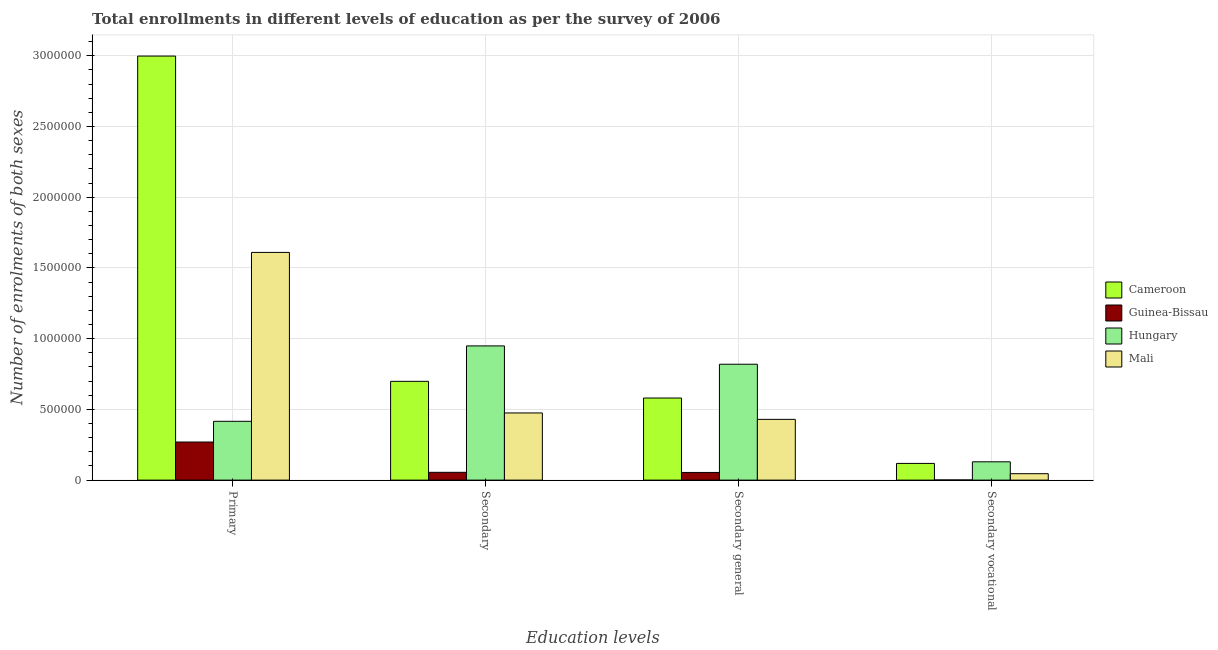What is the label of the 1st group of bars from the left?
Your answer should be very brief. Primary. What is the number of enrolments in secondary vocational education in Mali?
Your answer should be very brief. 4.54e+04. Across all countries, what is the maximum number of enrolments in primary education?
Provide a short and direct response. 3.00e+06. Across all countries, what is the minimum number of enrolments in secondary education?
Keep it short and to the point. 5.52e+04. In which country was the number of enrolments in secondary education maximum?
Offer a very short reply. Hungary. In which country was the number of enrolments in secondary vocational education minimum?
Ensure brevity in your answer.  Guinea-Bissau. What is the total number of enrolments in primary education in the graph?
Offer a terse response. 5.29e+06. What is the difference between the number of enrolments in secondary vocational education in Guinea-Bissau and that in Cameroon?
Your response must be concise. -1.17e+05. What is the difference between the number of enrolments in secondary general education in Guinea-Bissau and the number of enrolments in secondary education in Cameroon?
Your answer should be very brief. -6.44e+05. What is the average number of enrolments in primary education per country?
Your response must be concise. 1.32e+06. What is the difference between the number of enrolments in secondary vocational education and number of enrolments in primary education in Guinea-Bissau?
Ensure brevity in your answer.  -2.68e+05. In how many countries, is the number of enrolments in secondary education greater than 300000 ?
Keep it short and to the point. 3. What is the ratio of the number of enrolments in secondary general education in Cameroon to that in Hungary?
Offer a very short reply. 0.71. Is the difference between the number of enrolments in secondary vocational education in Cameroon and Hungary greater than the difference between the number of enrolments in secondary education in Cameroon and Hungary?
Ensure brevity in your answer.  Yes. What is the difference between the highest and the second highest number of enrolments in secondary vocational education?
Give a very brief answer. 1.14e+04. What is the difference between the highest and the lowest number of enrolments in secondary vocational education?
Provide a succinct answer. 1.28e+05. Is the sum of the number of enrolments in secondary general education in Cameroon and Guinea-Bissau greater than the maximum number of enrolments in primary education across all countries?
Your response must be concise. No. Is it the case that in every country, the sum of the number of enrolments in secondary vocational education and number of enrolments in secondary education is greater than the sum of number of enrolments in primary education and number of enrolments in secondary general education?
Make the answer very short. No. What does the 4th bar from the left in Primary represents?
Give a very brief answer. Mali. What does the 4th bar from the right in Secondary represents?
Your answer should be compact. Cameroon. How many bars are there?
Make the answer very short. 16. How many countries are there in the graph?
Offer a very short reply. 4. Does the graph contain grids?
Give a very brief answer. Yes. Where does the legend appear in the graph?
Keep it short and to the point. Center right. How many legend labels are there?
Your answer should be very brief. 4. What is the title of the graph?
Offer a terse response. Total enrollments in different levels of education as per the survey of 2006. Does "Guatemala" appear as one of the legend labels in the graph?
Offer a very short reply. No. What is the label or title of the X-axis?
Keep it short and to the point. Education levels. What is the label or title of the Y-axis?
Keep it short and to the point. Number of enrolments of both sexes. What is the Number of enrolments of both sexes of Cameroon in Primary?
Offer a very short reply. 3.00e+06. What is the Number of enrolments of both sexes of Guinea-Bissau in Primary?
Your response must be concise. 2.69e+05. What is the Number of enrolments of both sexes in Hungary in Primary?
Your answer should be very brief. 4.16e+05. What is the Number of enrolments of both sexes of Mali in Primary?
Provide a short and direct response. 1.61e+06. What is the Number of enrolments of both sexes of Cameroon in Secondary?
Provide a succinct answer. 6.98e+05. What is the Number of enrolments of both sexes in Guinea-Bissau in Secondary?
Your response must be concise. 5.52e+04. What is the Number of enrolments of both sexes of Hungary in Secondary?
Your answer should be very brief. 9.49e+05. What is the Number of enrolments of both sexes in Mali in Secondary?
Keep it short and to the point. 4.75e+05. What is the Number of enrolments of both sexes in Cameroon in Secondary general?
Keep it short and to the point. 5.80e+05. What is the Number of enrolments of both sexes in Guinea-Bissau in Secondary general?
Offer a very short reply. 5.42e+04. What is the Number of enrolments of both sexes of Hungary in Secondary general?
Your answer should be very brief. 8.19e+05. What is the Number of enrolments of both sexes in Mali in Secondary general?
Ensure brevity in your answer.  4.30e+05. What is the Number of enrolments of both sexes in Cameroon in Secondary vocational?
Give a very brief answer. 1.18e+05. What is the Number of enrolments of both sexes in Guinea-Bissau in Secondary vocational?
Provide a short and direct response. 977. What is the Number of enrolments of both sexes in Hungary in Secondary vocational?
Provide a short and direct response. 1.29e+05. What is the Number of enrolments of both sexes in Mali in Secondary vocational?
Your answer should be very brief. 4.54e+04. Across all Education levels, what is the maximum Number of enrolments of both sexes of Cameroon?
Make the answer very short. 3.00e+06. Across all Education levels, what is the maximum Number of enrolments of both sexes in Guinea-Bissau?
Provide a short and direct response. 2.69e+05. Across all Education levels, what is the maximum Number of enrolments of both sexes in Hungary?
Ensure brevity in your answer.  9.49e+05. Across all Education levels, what is the maximum Number of enrolments of both sexes in Mali?
Keep it short and to the point. 1.61e+06. Across all Education levels, what is the minimum Number of enrolments of both sexes in Cameroon?
Your answer should be compact. 1.18e+05. Across all Education levels, what is the minimum Number of enrolments of both sexes in Guinea-Bissau?
Your response must be concise. 977. Across all Education levels, what is the minimum Number of enrolments of both sexes of Hungary?
Your answer should be very brief. 1.29e+05. Across all Education levels, what is the minimum Number of enrolments of both sexes of Mali?
Keep it short and to the point. 4.54e+04. What is the total Number of enrolments of both sexes of Cameroon in the graph?
Offer a terse response. 4.40e+06. What is the total Number of enrolments of both sexes in Guinea-Bissau in the graph?
Ensure brevity in your answer.  3.80e+05. What is the total Number of enrolments of both sexes in Hungary in the graph?
Offer a very short reply. 2.31e+06. What is the total Number of enrolments of both sexes in Mali in the graph?
Offer a terse response. 2.56e+06. What is the difference between the Number of enrolments of both sexes in Cameroon in Primary and that in Secondary?
Offer a terse response. 2.30e+06. What is the difference between the Number of enrolments of both sexes of Guinea-Bissau in Primary and that in Secondary?
Offer a terse response. 2.14e+05. What is the difference between the Number of enrolments of both sexes of Hungary in Primary and that in Secondary?
Provide a short and direct response. -5.33e+05. What is the difference between the Number of enrolments of both sexes of Mali in Primary and that in Secondary?
Provide a succinct answer. 1.14e+06. What is the difference between the Number of enrolments of both sexes in Cameroon in Primary and that in Secondary general?
Provide a succinct answer. 2.42e+06. What is the difference between the Number of enrolments of both sexes of Guinea-Bissau in Primary and that in Secondary general?
Provide a succinct answer. 2.15e+05. What is the difference between the Number of enrolments of both sexes of Hungary in Primary and that in Secondary general?
Keep it short and to the point. -4.04e+05. What is the difference between the Number of enrolments of both sexes of Mali in Primary and that in Secondary general?
Give a very brief answer. 1.18e+06. What is the difference between the Number of enrolments of both sexes of Cameroon in Primary and that in Secondary vocational?
Your answer should be compact. 2.88e+06. What is the difference between the Number of enrolments of both sexes in Guinea-Bissau in Primary and that in Secondary vocational?
Offer a very short reply. 2.68e+05. What is the difference between the Number of enrolments of both sexes in Hungary in Primary and that in Secondary vocational?
Your answer should be compact. 2.86e+05. What is the difference between the Number of enrolments of both sexes in Mali in Primary and that in Secondary vocational?
Make the answer very short. 1.56e+06. What is the difference between the Number of enrolments of both sexes in Cameroon in Secondary and that in Secondary general?
Make the answer very short. 1.18e+05. What is the difference between the Number of enrolments of both sexes of Guinea-Bissau in Secondary and that in Secondary general?
Give a very brief answer. 977. What is the difference between the Number of enrolments of both sexes in Hungary in Secondary and that in Secondary general?
Your response must be concise. 1.29e+05. What is the difference between the Number of enrolments of both sexes of Mali in Secondary and that in Secondary general?
Give a very brief answer. 4.54e+04. What is the difference between the Number of enrolments of both sexes of Cameroon in Secondary and that in Secondary vocational?
Provide a short and direct response. 5.80e+05. What is the difference between the Number of enrolments of both sexes of Guinea-Bissau in Secondary and that in Secondary vocational?
Your answer should be compact. 5.42e+04. What is the difference between the Number of enrolments of both sexes of Hungary in Secondary and that in Secondary vocational?
Your response must be concise. 8.19e+05. What is the difference between the Number of enrolments of both sexes of Mali in Secondary and that in Secondary vocational?
Give a very brief answer. 4.30e+05. What is the difference between the Number of enrolments of both sexes in Cameroon in Secondary general and that in Secondary vocational?
Offer a terse response. 4.62e+05. What is the difference between the Number of enrolments of both sexes in Guinea-Bissau in Secondary general and that in Secondary vocational?
Your answer should be very brief. 5.32e+04. What is the difference between the Number of enrolments of both sexes in Hungary in Secondary general and that in Secondary vocational?
Your answer should be very brief. 6.90e+05. What is the difference between the Number of enrolments of both sexes in Mali in Secondary general and that in Secondary vocational?
Your answer should be compact. 3.84e+05. What is the difference between the Number of enrolments of both sexes of Cameroon in Primary and the Number of enrolments of both sexes of Guinea-Bissau in Secondary?
Your response must be concise. 2.94e+06. What is the difference between the Number of enrolments of both sexes of Cameroon in Primary and the Number of enrolments of both sexes of Hungary in Secondary?
Provide a succinct answer. 2.05e+06. What is the difference between the Number of enrolments of both sexes in Cameroon in Primary and the Number of enrolments of both sexes in Mali in Secondary?
Provide a short and direct response. 2.52e+06. What is the difference between the Number of enrolments of both sexes of Guinea-Bissau in Primary and the Number of enrolments of both sexes of Hungary in Secondary?
Offer a very short reply. -6.80e+05. What is the difference between the Number of enrolments of both sexes of Guinea-Bissau in Primary and the Number of enrolments of both sexes of Mali in Secondary?
Give a very brief answer. -2.06e+05. What is the difference between the Number of enrolments of both sexes in Hungary in Primary and the Number of enrolments of both sexes in Mali in Secondary?
Your answer should be very brief. -5.91e+04. What is the difference between the Number of enrolments of both sexes of Cameroon in Primary and the Number of enrolments of both sexes of Guinea-Bissau in Secondary general?
Make the answer very short. 2.94e+06. What is the difference between the Number of enrolments of both sexes of Cameroon in Primary and the Number of enrolments of both sexes of Hungary in Secondary general?
Your answer should be compact. 2.18e+06. What is the difference between the Number of enrolments of both sexes in Cameroon in Primary and the Number of enrolments of both sexes in Mali in Secondary general?
Offer a very short reply. 2.57e+06. What is the difference between the Number of enrolments of both sexes of Guinea-Bissau in Primary and the Number of enrolments of both sexes of Hungary in Secondary general?
Make the answer very short. -5.50e+05. What is the difference between the Number of enrolments of both sexes of Guinea-Bissau in Primary and the Number of enrolments of both sexes of Mali in Secondary general?
Make the answer very short. -1.60e+05. What is the difference between the Number of enrolments of both sexes of Hungary in Primary and the Number of enrolments of both sexes of Mali in Secondary general?
Provide a short and direct response. -1.37e+04. What is the difference between the Number of enrolments of both sexes in Cameroon in Primary and the Number of enrolments of both sexes in Guinea-Bissau in Secondary vocational?
Provide a succinct answer. 3.00e+06. What is the difference between the Number of enrolments of both sexes in Cameroon in Primary and the Number of enrolments of both sexes in Hungary in Secondary vocational?
Your answer should be compact. 2.87e+06. What is the difference between the Number of enrolments of both sexes in Cameroon in Primary and the Number of enrolments of both sexes in Mali in Secondary vocational?
Provide a succinct answer. 2.95e+06. What is the difference between the Number of enrolments of both sexes of Guinea-Bissau in Primary and the Number of enrolments of both sexes of Hungary in Secondary vocational?
Your response must be concise. 1.40e+05. What is the difference between the Number of enrolments of both sexes of Guinea-Bissau in Primary and the Number of enrolments of both sexes of Mali in Secondary vocational?
Provide a short and direct response. 2.24e+05. What is the difference between the Number of enrolments of both sexes in Hungary in Primary and the Number of enrolments of both sexes in Mali in Secondary vocational?
Keep it short and to the point. 3.70e+05. What is the difference between the Number of enrolments of both sexes of Cameroon in Secondary and the Number of enrolments of both sexes of Guinea-Bissau in Secondary general?
Your answer should be very brief. 6.44e+05. What is the difference between the Number of enrolments of both sexes of Cameroon in Secondary and the Number of enrolments of both sexes of Hungary in Secondary general?
Keep it short and to the point. -1.21e+05. What is the difference between the Number of enrolments of both sexes in Cameroon in Secondary and the Number of enrolments of both sexes in Mali in Secondary general?
Provide a succinct answer. 2.69e+05. What is the difference between the Number of enrolments of both sexes of Guinea-Bissau in Secondary and the Number of enrolments of both sexes of Hungary in Secondary general?
Give a very brief answer. -7.64e+05. What is the difference between the Number of enrolments of both sexes of Guinea-Bissau in Secondary and the Number of enrolments of both sexes of Mali in Secondary general?
Offer a terse response. -3.74e+05. What is the difference between the Number of enrolments of both sexes in Hungary in Secondary and the Number of enrolments of both sexes in Mali in Secondary general?
Offer a terse response. 5.19e+05. What is the difference between the Number of enrolments of both sexes of Cameroon in Secondary and the Number of enrolments of both sexes of Guinea-Bissau in Secondary vocational?
Give a very brief answer. 6.97e+05. What is the difference between the Number of enrolments of both sexes in Cameroon in Secondary and the Number of enrolments of both sexes in Hungary in Secondary vocational?
Your answer should be very brief. 5.69e+05. What is the difference between the Number of enrolments of both sexes in Cameroon in Secondary and the Number of enrolments of both sexes in Mali in Secondary vocational?
Your answer should be very brief. 6.53e+05. What is the difference between the Number of enrolments of both sexes in Guinea-Bissau in Secondary and the Number of enrolments of both sexes in Hungary in Secondary vocational?
Offer a very short reply. -7.43e+04. What is the difference between the Number of enrolments of both sexes in Guinea-Bissau in Secondary and the Number of enrolments of both sexes in Mali in Secondary vocational?
Give a very brief answer. 9754. What is the difference between the Number of enrolments of both sexes of Hungary in Secondary and the Number of enrolments of both sexes of Mali in Secondary vocational?
Offer a very short reply. 9.03e+05. What is the difference between the Number of enrolments of both sexes of Cameroon in Secondary general and the Number of enrolments of both sexes of Guinea-Bissau in Secondary vocational?
Your response must be concise. 5.79e+05. What is the difference between the Number of enrolments of both sexes in Cameroon in Secondary general and the Number of enrolments of both sexes in Hungary in Secondary vocational?
Give a very brief answer. 4.51e+05. What is the difference between the Number of enrolments of both sexes of Cameroon in Secondary general and the Number of enrolments of both sexes of Mali in Secondary vocational?
Offer a very short reply. 5.35e+05. What is the difference between the Number of enrolments of both sexes in Guinea-Bissau in Secondary general and the Number of enrolments of both sexes in Hungary in Secondary vocational?
Give a very brief answer. -7.52e+04. What is the difference between the Number of enrolments of both sexes in Guinea-Bissau in Secondary general and the Number of enrolments of both sexes in Mali in Secondary vocational?
Your response must be concise. 8777. What is the difference between the Number of enrolments of both sexes of Hungary in Secondary general and the Number of enrolments of both sexes of Mali in Secondary vocational?
Your answer should be compact. 7.74e+05. What is the average Number of enrolments of both sexes in Cameroon per Education levels?
Offer a very short reply. 1.10e+06. What is the average Number of enrolments of both sexes in Guinea-Bissau per Education levels?
Keep it short and to the point. 9.49e+04. What is the average Number of enrolments of both sexes of Hungary per Education levels?
Make the answer very short. 5.78e+05. What is the average Number of enrolments of both sexes of Mali per Education levels?
Give a very brief answer. 6.40e+05. What is the difference between the Number of enrolments of both sexes of Cameroon and Number of enrolments of both sexes of Guinea-Bissau in Primary?
Provide a short and direct response. 2.73e+06. What is the difference between the Number of enrolments of both sexes in Cameroon and Number of enrolments of both sexes in Hungary in Primary?
Give a very brief answer. 2.58e+06. What is the difference between the Number of enrolments of both sexes in Cameroon and Number of enrolments of both sexes in Mali in Primary?
Offer a terse response. 1.39e+06. What is the difference between the Number of enrolments of both sexes of Guinea-Bissau and Number of enrolments of both sexes of Hungary in Primary?
Provide a short and direct response. -1.47e+05. What is the difference between the Number of enrolments of both sexes of Guinea-Bissau and Number of enrolments of both sexes of Mali in Primary?
Offer a terse response. -1.34e+06. What is the difference between the Number of enrolments of both sexes of Hungary and Number of enrolments of both sexes of Mali in Primary?
Provide a short and direct response. -1.19e+06. What is the difference between the Number of enrolments of both sexes of Cameroon and Number of enrolments of both sexes of Guinea-Bissau in Secondary?
Ensure brevity in your answer.  6.43e+05. What is the difference between the Number of enrolments of both sexes in Cameroon and Number of enrolments of both sexes in Hungary in Secondary?
Offer a terse response. -2.50e+05. What is the difference between the Number of enrolments of both sexes in Cameroon and Number of enrolments of both sexes in Mali in Secondary?
Provide a short and direct response. 2.23e+05. What is the difference between the Number of enrolments of both sexes in Guinea-Bissau and Number of enrolments of both sexes in Hungary in Secondary?
Make the answer very short. -8.94e+05. What is the difference between the Number of enrolments of both sexes in Guinea-Bissau and Number of enrolments of both sexes in Mali in Secondary?
Provide a short and direct response. -4.20e+05. What is the difference between the Number of enrolments of both sexes of Hungary and Number of enrolments of both sexes of Mali in Secondary?
Keep it short and to the point. 4.74e+05. What is the difference between the Number of enrolments of both sexes of Cameroon and Number of enrolments of both sexes of Guinea-Bissau in Secondary general?
Your answer should be very brief. 5.26e+05. What is the difference between the Number of enrolments of both sexes of Cameroon and Number of enrolments of both sexes of Hungary in Secondary general?
Give a very brief answer. -2.39e+05. What is the difference between the Number of enrolments of both sexes of Cameroon and Number of enrolments of both sexes of Mali in Secondary general?
Provide a short and direct response. 1.51e+05. What is the difference between the Number of enrolments of both sexes in Guinea-Bissau and Number of enrolments of both sexes in Hungary in Secondary general?
Your answer should be compact. -7.65e+05. What is the difference between the Number of enrolments of both sexes in Guinea-Bissau and Number of enrolments of both sexes in Mali in Secondary general?
Give a very brief answer. -3.75e+05. What is the difference between the Number of enrolments of both sexes in Hungary and Number of enrolments of both sexes in Mali in Secondary general?
Your answer should be very brief. 3.90e+05. What is the difference between the Number of enrolments of both sexes in Cameroon and Number of enrolments of both sexes in Guinea-Bissau in Secondary vocational?
Offer a very short reply. 1.17e+05. What is the difference between the Number of enrolments of both sexes in Cameroon and Number of enrolments of both sexes in Hungary in Secondary vocational?
Your answer should be compact. -1.14e+04. What is the difference between the Number of enrolments of both sexes of Cameroon and Number of enrolments of both sexes of Mali in Secondary vocational?
Offer a very short reply. 7.26e+04. What is the difference between the Number of enrolments of both sexes in Guinea-Bissau and Number of enrolments of both sexes in Hungary in Secondary vocational?
Give a very brief answer. -1.28e+05. What is the difference between the Number of enrolments of both sexes in Guinea-Bissau and Number of enrolments of both sexes in Mali in Secondary vocational?
Offer a terse response. -4.44e+04. What is the difference between the Number of enrolments of both sexes in Hungary and Number of enrolments of both sexes in Mali in Secondary vocational?
Make the answer very short. 8.40e+04. What is the ratio of the Number of enrolments of both sexes in Cameroon in Primary to that in Secondary?
Provide a short and direct response. 4.29. What is the ratio of the Number of enrolments of both sexes of Guinea-Bissau in Primary to that in Secondary?
Provide a short and direct response. 4.88. What is the ratio of the Number of enrolments of both sexes of Hungary in Primary to that in Secondary?
Your answer should be very brief. 0.44. What is the ratio of the Number of enrolments of both sexes in Mali in Primary to that in Secondary?
Provide a short and direct response. 3.39. What is the ratio of the Number of enrolments of both sexes of Cameroon in Primary to that in Secondary general?
Provide a succinct answer. 5.17. What is the ratio of the Number of enrolments of both sexes of Guinea-Bissau in Primary to that in Secondary general?
Ensure brevity in your answer.  4.97. What is the ratio of the Number of enrolments of both sexes in Hungary in Primary to that in Secondary general?
Give a very brief answer. 0.51. What is the ratio of the Number of enrolments of both sexes in Mali in Primary to that in Secondary general?
Your response must be concise. 3.75. What is the ratio of the Number of enrolments of both sexes in Cameroon in Primary to that in Secondary vocational?
Offer a very short reply. 25.4. What is the ratio of the Number of enrolments of both sexes in Guinea-Bissau in Primary to that in Secondary vocational?
Keep it short and to the point. 275.63. What is the ratio of the Number of enrolments of both sexes in Hungary in Primary to that in Secondary vocational?
Give a very brief answer. 3.21. What is the ratio of the Number of enrolments of both sexes in Mali in Primary to that in Secondary vocational?
Provide a succinct answer. 35.44. What is the ratio of the Number of enrolments of both sexes in Cameroon in Secondary to that in Secondary general?
Keep it short and to the point. 1.2. What is the ratio of the Number of enrolments of both sexes of Hungary in Secondary to that in Secondary general?
Ensure brevity in your answer.  1.16. What is the ratio of the Number of enrolments of both sexes of Mali in Secondary to that in Secondary general?
Keep it short and to the point. 1.11. What is the ratio of the Number of enrolments of both sexes of Cameroon in Secondary to that in Secondary vocational?
Provide a short and direct response. 5.92. What is the ratio of the Number of enrolments of both sexes of Guinea-Bissau in Secondary to that in Secondary vocational?
Give a very brief answer. 56.47. What is the ratio of the Number of enrolments of both sexes of Hungary in Secondary to that in Secondary vocational?
Ensure brevity in your answer.  7.33. What is the ratio of the Number of enrolments of both sexes in Mali in Secondary to that in Secondary vocational?
Ensure brevity in your answer.  10.46. What is the ratio of the Number of enrolments of both sexes in Cameroon in Secondary general to that in Secondary vocational?
Your answer should be compact. 4.92. What is the ratio of the Number of enrolments of both sexes of Guinea-Bissau in Secondary general to that in Secondary vocational?
Provide a short and direct response. 55.47. What is the ratio of the Number of enrolments of both sexes in Hungary in Secondary general to that in Secondary vocational?
Keep it short and to the point. 6.33. What is the ratio of the Number of enrolments of both sexes of Mali in Secondary general to that in Secondary vocational?
Your answer should be compact. 9.46. What is the difference between the highest and the second highest Number of enrolments of both sexes in Cameroon?
Ensure brevity in your answer.  2.30e+06. What is the difference between the highest and the second highest Number of enrolments of both sexes of Guinea-Bissau?
Your answer should be compact. 2.14e+05. What is the difference between the highest and the second highest Number of enrolments of both sexes of Hungary?
Your answer should be compact. 1.29e+05. What is the difference between the highest and the second highest Number of enrolments of both sexes in Mali?
Give a very brief answer. 1.14e+06. What is the difference between the highest and the lowest Number of enrolments of both sexes of Cameroon?
Ensure brevity in your answer.  2.88e+06. What is the difference between the highest and the lowest Number of enrolments of both sexes of Guinea-Bissau?
Keep it short and to the point. 2.68e+05. What is the difference between the highest and the lowest Number of enrolments of both sexes of Hungary?
Ensure brevity in your answer.  8.19e+05. What is the difference between the highest and the lowest Number of enrolments of both sexes of Mali?
Your answer should be compact. 1.56e+06. 